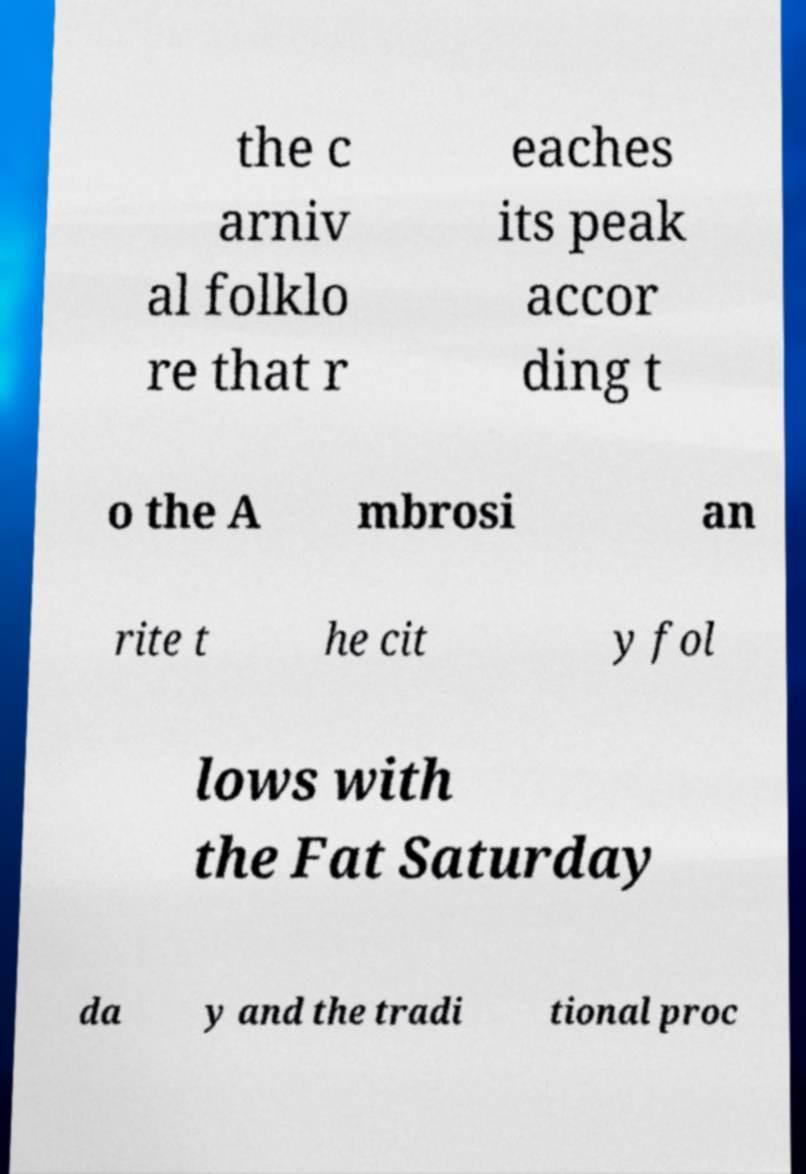Could you extract and type out the text from this image? the c arniv al folklo re that r eaches its peak accor ding t o the A mbrosi an rite t he cit y fol lows with the Fat Saturday da y and the tradi tional proc 